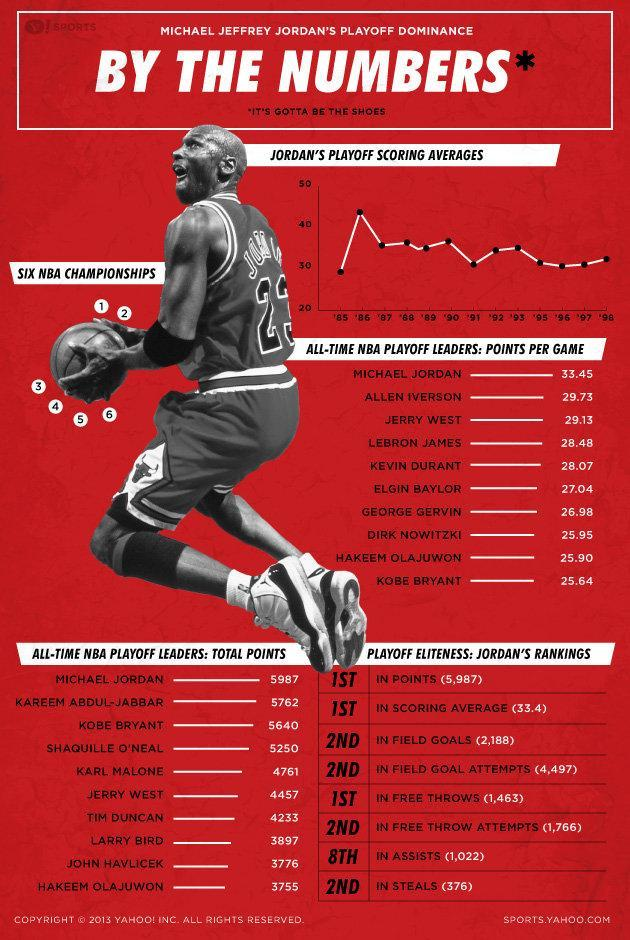Who has won six NBA championships?
Answer the question with a short phrase. Jordan 